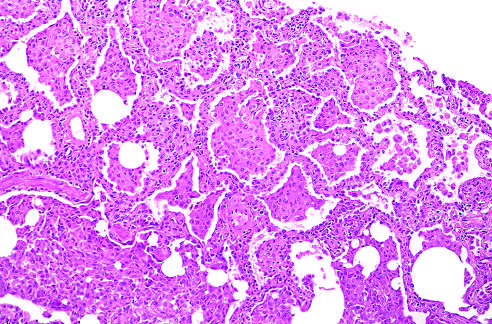what is there of large numbers of macrophages within the alveolar spaces with only slight fibrous thickening of the alveolar walls?
Answer the question using a single word or phrase. Accumulation of large numbers of macrophage 